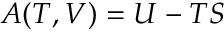<formula> <loc_0><loc_0><loc_500><loc_500>A ( T , V ) = U - T S</formula> 